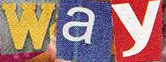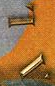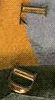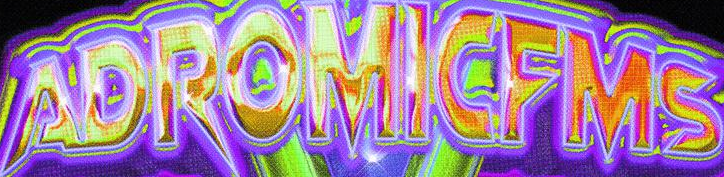What text appears in these images from left to right, separated by a semicolon? way; AL; LD; ADROMICFMS 